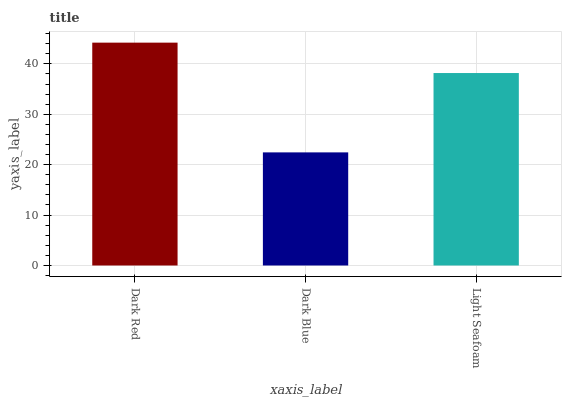Is Dark Blue the minimum?
Answer yes or no. Yes. Is Dark Red the maximum?
Answer yes or no. Yes. Is Light Seafoam the minimum?
Answer yes or no. No. Is Light Seafoam the maximum?
Answer yes or no. No. Is Light Seafoam greater than Dark Blue?
Answer yes or no. Yes. Is Dark Blue less than Light Seafoam?
Answer yes or no. Yes. Is Dark Blue greater than Light Seafoam?
Answer yes or no. No. Is Light Seafoam less than Dark Blue?
Answer yes or no. No. Is Light Seafoam the high median?
Answer yes or no. Yes. Is Light Seafoam the low median?
Answer yes or no. Yes. Is Dark Blue the high median?
Answer yes or no. No. Is Dark Blue the low median?
Answer yes or no. No. 